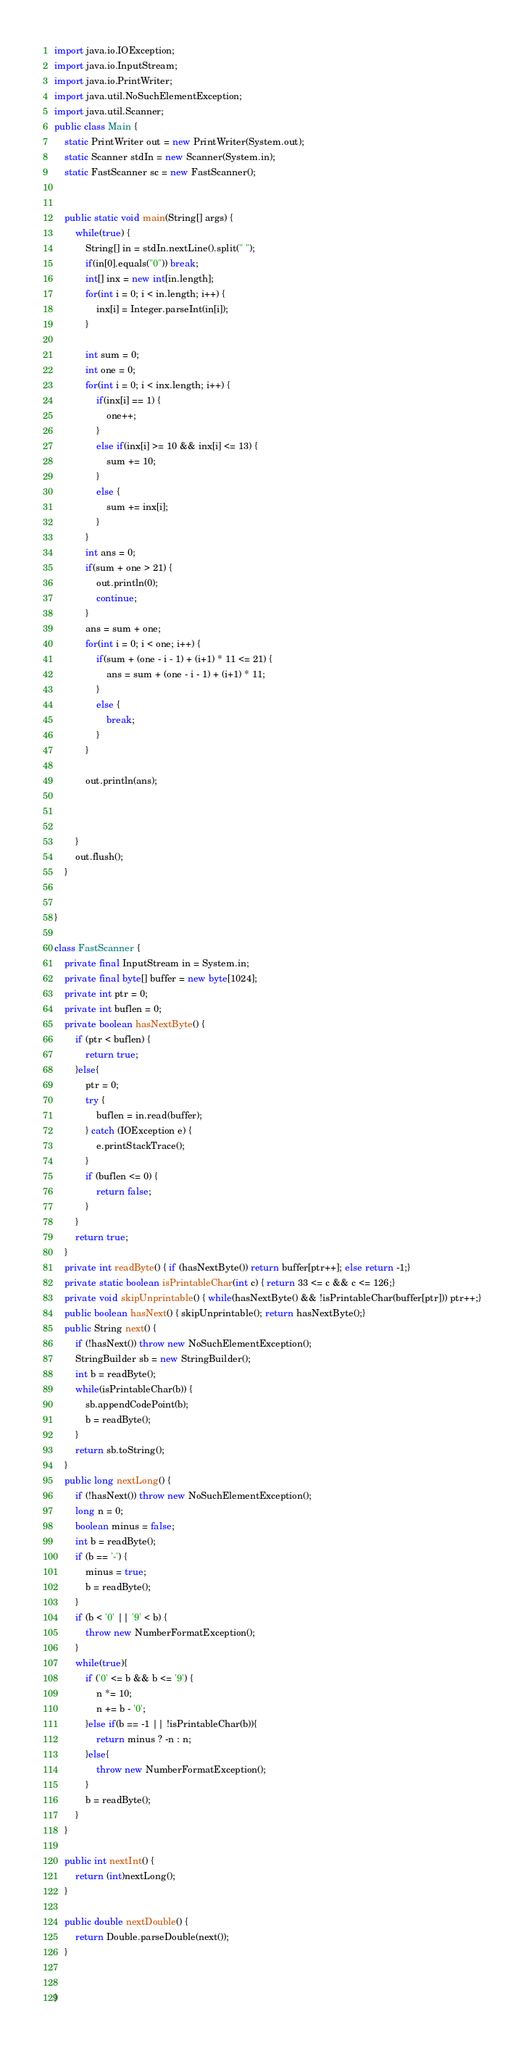Convert code to text. <code><loc_0><loc_0><loc_500><loc_500><_Java_>
import java.io.IOException;
import java.io.InputStream;
import java.io.PrintWriter;
import java.util.NoSuchElementException;
import java.util.Scanner;
public class Main {
	static PrintWriter out = new PrintWriter(System.out);
	static Scanner stdIn = new Scanner(System.in);
	static FastScanner sc = new FastScanner();

	
	public static void main(String[] args) {
		while(true) {
			String[] in = stdIn.nextLine().split(" ");
			if(in[0].equals("0")) break;
			int[] inx = new int[in.length];
			for(int i = 0; i < in.length; i++) {
				inx[i] = Integer.parseInt(in[i]);
			}
			
			int sum = 0;
			int one = 0;
			for(int i = 0; i < inx.length; i++) {
				if(inx[i] == 1) {
					one++;
				}
				else if(inx[i] >= 10 && inx[i] <= 13) {
					sum += 10;
				}
				else {
					sum += inx[i];
				}
			}
			int ans = 0;
			if(sum + one > 21) {
				out.println(0);
				continue;
			}
			ans = sum + one;
			for(int i = 0; i < one; i++) {
				if(sum + (one - i - 1) + (i+1) * 11 <= 21) {
					ans = sum + (one - i - 1) + (i+1) * 11;
				}
				else {
					break;
				}
			}
			
			out.println(ans);
			
			
			
		}
		out.flush();
	}


}

class FastScanner {
    private final InputStream in = System.in;
    private final byte[] buffer = new byte[1024];
    private int ptr = 0;
    private int buflen = 0;
    private boolean hasNextByte() {
        if (ptr < buflen) {
            return true;
        }else{
            ptr = 0;
            try {
                buflen = in.read(buffer);
            } catch (IOException e) {
                e.printStackTrace();
            }
            if (buflen <= 0) {
                return false;
            }
        }
        return true;
    }
    private int readByte() { if (hasNextByte()) return buffer[ptr++]; else return -1;}
    private static boolean isPrintableChar(int c) { return 33 <= c && c <= 126;}
    private void skipUnprintable() { while(hasNextByte() && !isPrintableChar(buffer[ptr])) ptr++;}
    public boolean hasNext() { skipUnprintable(); return hasNextByte();}
    public String next() {
        if (!hasNext()) throw new NoSuchElementException();
        StringBuilder sb = new StringBuilder();
        int b = readByte();
        while(isPrintableChar(b)) {
            sb.appendCodePoint(b);
            b = readByte();
        }
        return sb.toString();
    }
    public long nextLong() {
        if (!hasNext()) throw new NoSuchElementException();
        long n = 0;
        boolean minus = false;
        int b = readByte();
        if (b == '-') {
            minus = true;
            b = readByte();
        }
        if (b < '0' || '9' < b) {
            throw new NumberFormatException();
        }
        while(true){
            if ('0' <= b && b <= '9') {
                n *= 10;
                n += b - '0';
            }else if(b == -1 || !isPrintableChar(b)){
                return minus ? -n : n;
            }else{
                throw new NumberFormatException();
            }
            b = readByte();
        }
    }
     
    public int nextInt() {
        return (int)nextLong();
    }
     
    public double nextDouble() {
        return Double.parseDouble(next());
    }
     
 
}</code> 